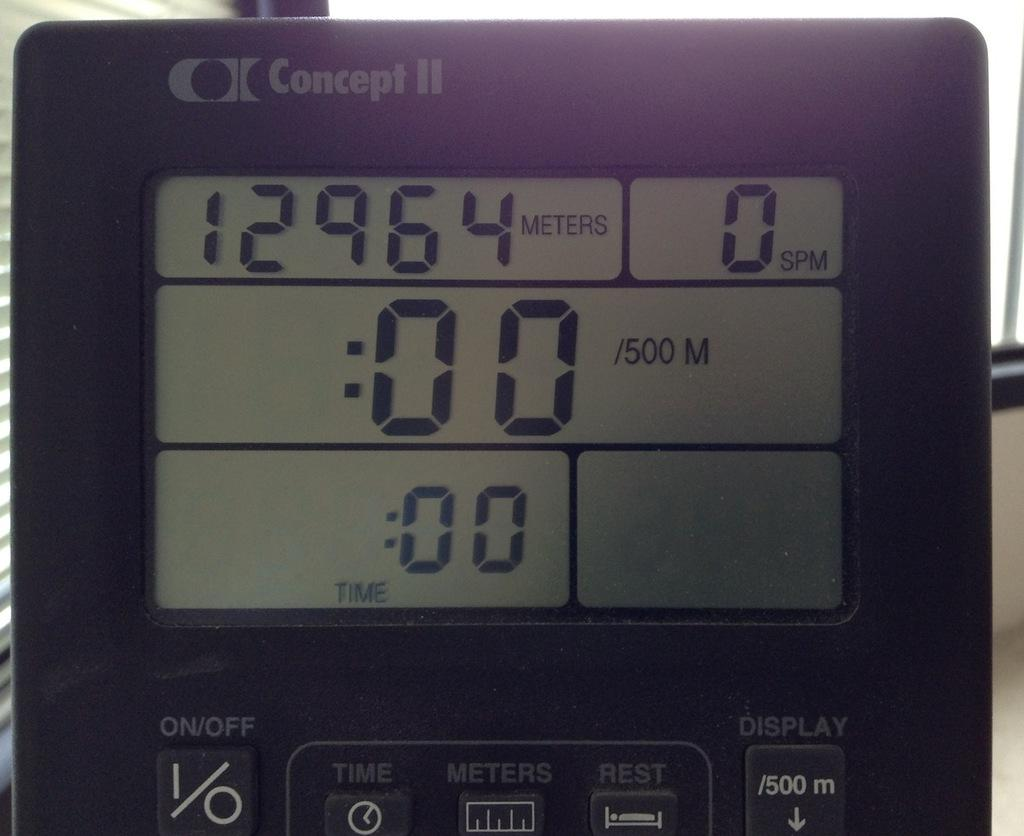<image>
Share a concise interpretation of the image provided. A Concept II display screen with numbers  on it. 